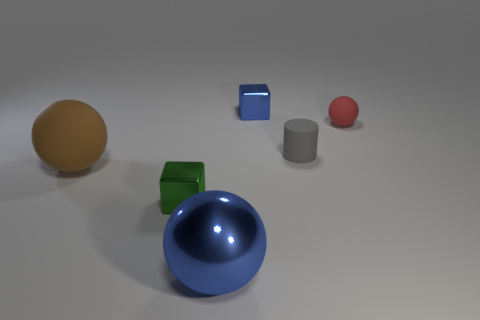There is a big brown rubber thing; what number of small shiny objects are behind it?
Offer a terse response. 1. What is the shape of the tiny thing that is the same material as the small cylinder?
Offer a terse response. Sphere. Is the number of red things that are behind the blue shiny block less than the number of matte objects in front of the tiny gray cylinder?
Your response must be concise. Yes. Is the number of small blue cylinders greater than the number of large blue spheres?
Your response must be concise. No. What is the material of the small gray thing?
Ensure brevity in your answer.  Rubber. What color is the metal object behind the gray cylinder?
Offer a very short reply. Blue. Is the number of blue objects that are to the right of the large shiny ball greater than the number of large blue spheres that are right of the blue block?
Your answer should be compact. Yes. There is a blue object behind the rubber ball to the right of the tiny object in front of the brown matte thing; how big is it?
Provide a short and direct response. Small. Is there a small matte cylinder of the same color as the large rubber object?
Your answer should be very brief. No. What number of metallic balls are there?
Ensure brevity in your answer.  1. 